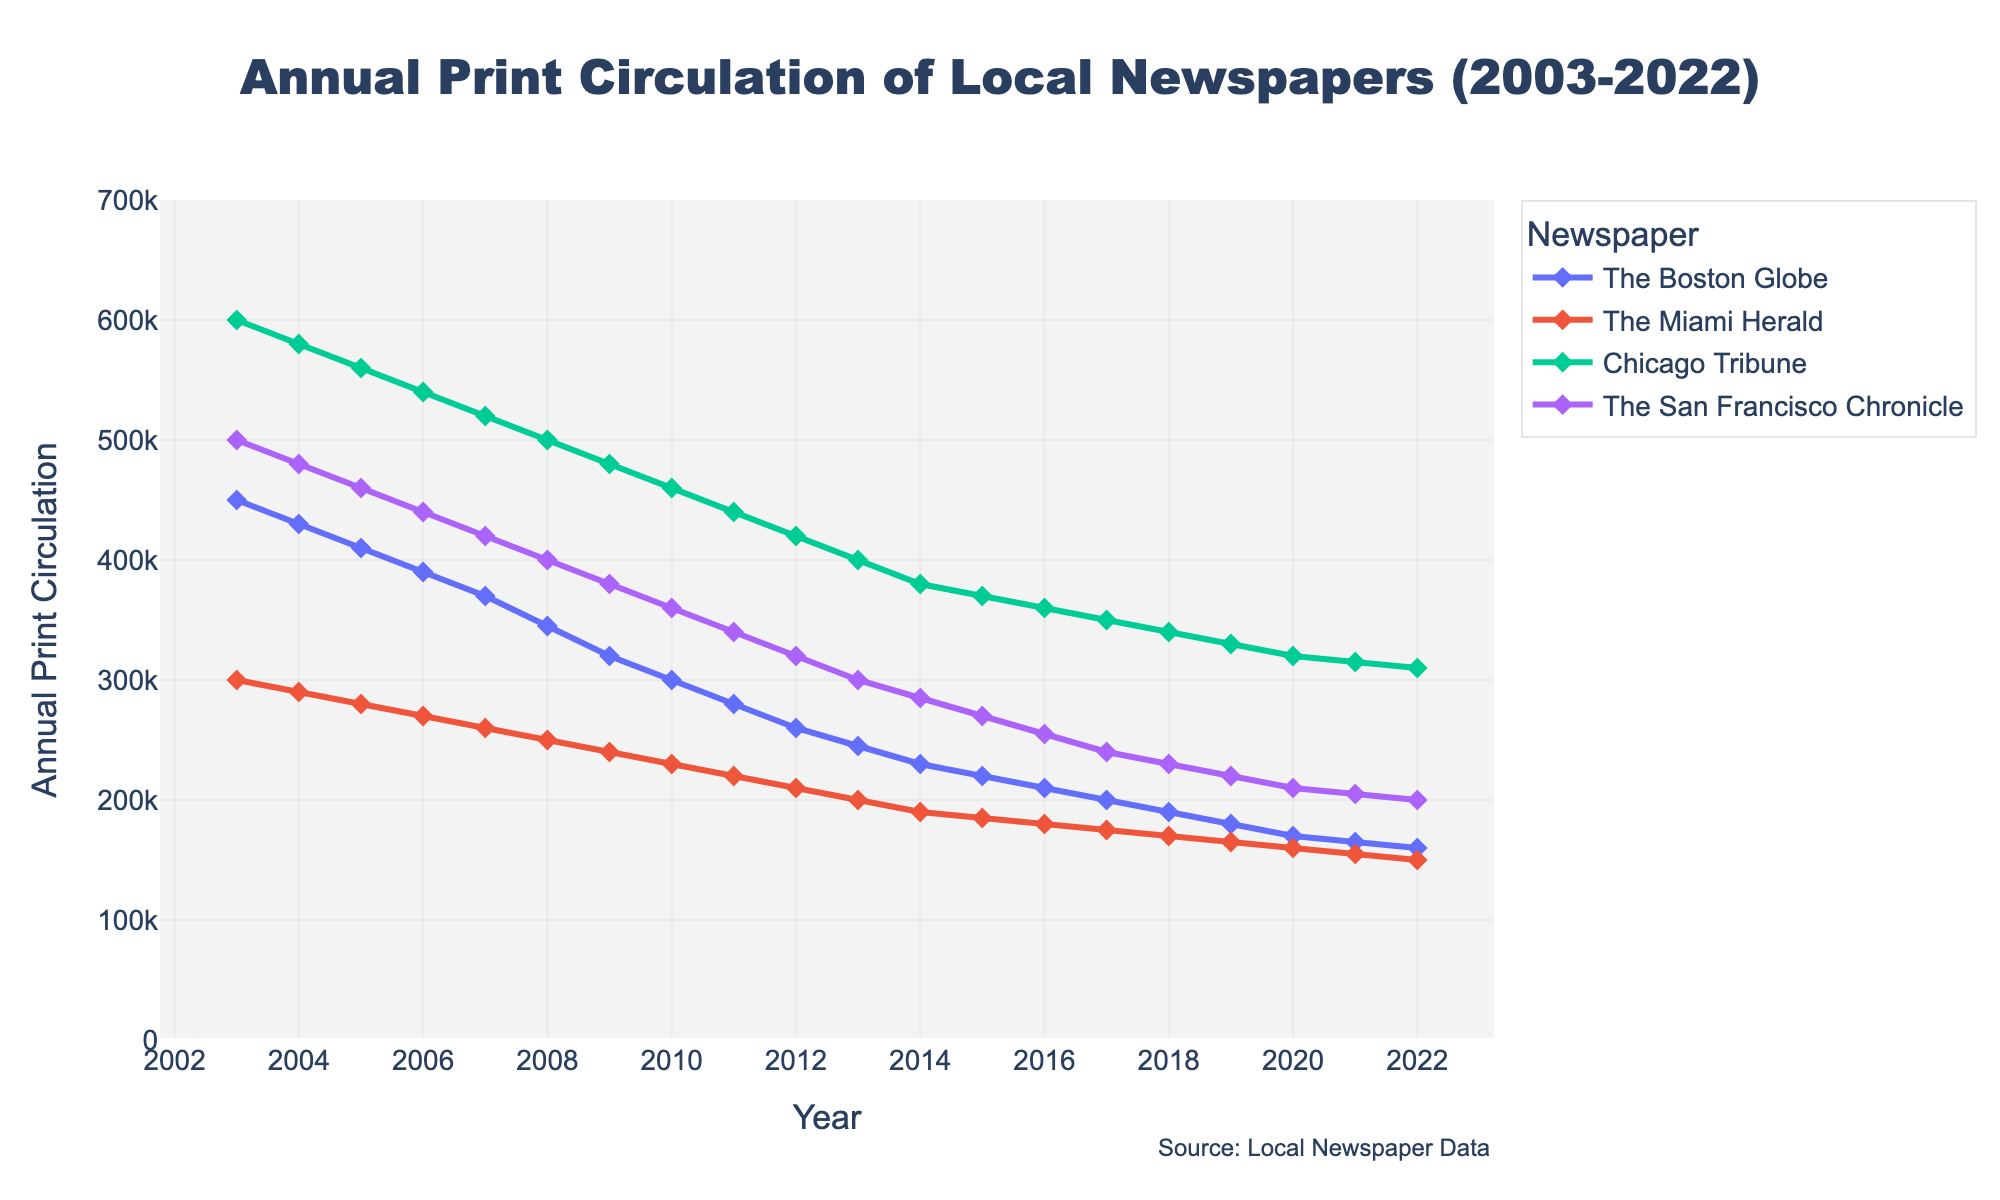How many regions are represented in the figure? The figure shows a separate line for each newspaper, and each newspaper represents a different region. Count the number of unique newspapers. There are four: The Boston Globe, The Miami Herald, Chicago Tribune, and The San Francisco Chronicle, each corresponding to Northeast, Southeast, Midwest, and West, respectively.
Answer: Four Which newspaper had the highest initial print circulation in 2003? Look at the start of each line at the year 2003 and compare the initial values. The Chicago Tribune starts at 600,000, which is higher than The Boston Globe, The Miami Herald, and The San Francisco Chronicle.
Answer: Chicago Tribune By how much did the print circulation of The Boston Globe decrease from 2003 to 2022? Find the value for The Boston Globe in 2003 (450,000) and in 2022 (160,000). Subtract the latter value from the former to get the decrease. 450,000 - 160,000 = 290,000.
Answer: 290,000 Which newspaper had the smallest decrease in circulation over the 20 years? Determine the change in circulation for each newspaper from 2003 to 2022, then find the smallest change. The Miami Herald decreased from 300,000 to 150,000 (150,000), The Boston Globe decreased by 290,000, the Chicago Tribune by 290,000, and The San Francisco Chronicle by 300,000. Therefore, The Miami Herald had the smallest decrease.
Answer: The Miami Herald In which year did The Miami Herald's circulation fall below 200,000? Locate the point where The Miami Herald's line crosses the 200,000 mark. This happens between 2012 (210,000) and 2013 (200,000), so it fell below in 2013.
Answer: 2013 Compare the rate of decrease of The Boston Globe and Chicago Tribune from 2003 to 2022. Which had a steeper decline? Calculate the total decrease for both newspapers over the 20-year period. The Boston Globe went from 450,000 to 160,000, a decrease of 290,000. Chicago Tribune went from 600,000 to 310,000, also a decrease of 290,000. Since both have the same amount of decrease, neither decline was steeper.
Answer: Equal decline What was the average annual circulation of The San Francisco Chronicle over the 20 years? Sum all the yearly values for The San Francisco Chronicle and divide by 20. Summation: 500,000 + 480,000 + 460,000 + 440,000 + 420,000 + 400,000 + 380,000 + 360,000 + 340,000 + 320,000 + 300,000 + 285,000 + 270,000 + 255,000 + 240,000 + 230,000 + 220,000 + 210,000 + 205,000 + 200,000 = 6,335,000. Average: 6,335,000 / 20 = 316,750.
Answer: 316,750 